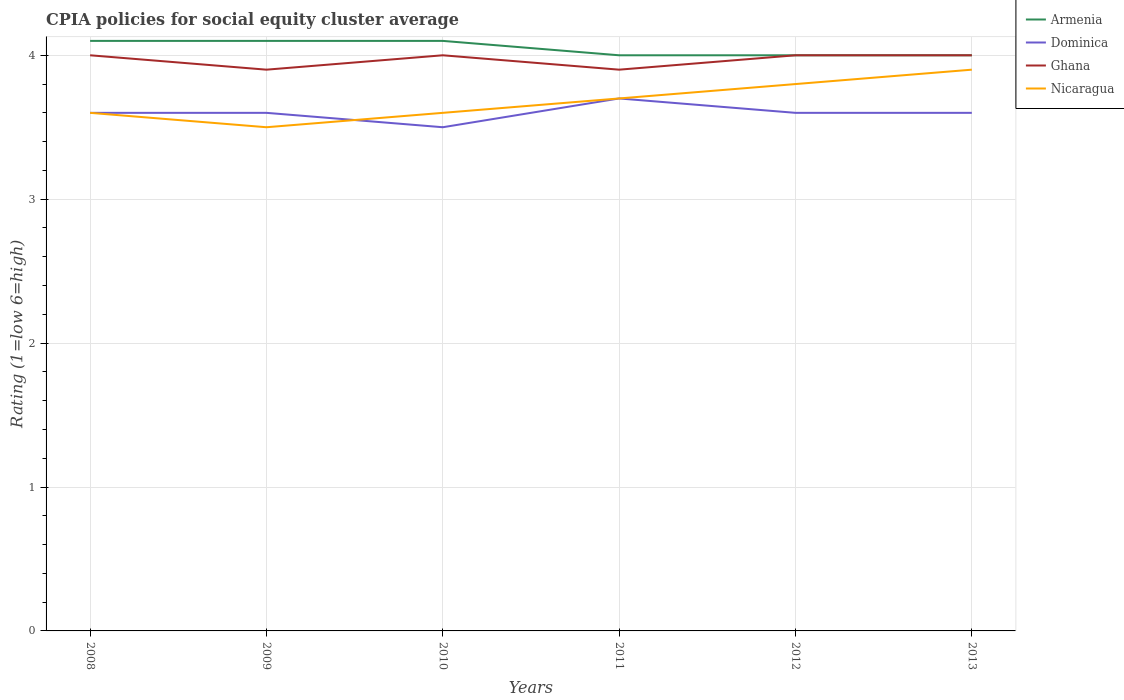How many different coloured lines are there?
Ensure brevity in your answer.  4. Does the line corresponding to Dominica intersect with the line corresponding to Ghana?
Make the answer very short. No. Across all years, what is the maximum CPIA rating in Ghana?
Keep it short and to the point. 3.9. What is the difference between the highest and the second highest CPIA rating in Dominica?
Your response must be concise. 0.2. Is the CPIA rating in Dominica strictly greater than the CPIA rating in Armenia over the years?
Give a very brief answer. Yes. How many lines are there?
Your answer should be very brief. 4. What is the difference between two consecutive major ticks on the Y-axis?
Keep it short and to the point. 1. Are the values on the major ticks of Y-axis written in scientific E-notation?
Offer a very short reply. No. What is the title of the graph?
Provide a short and direct response. CPIA policies for social equity cluster average. Does "Curacao" appear as one of the legend labels in the graph?
Make the answer very short. No. What is the label or title of the X-axis?
Offer a very short reply. Years. What is the label or title of the Y-axis?
Your answer should be compact. Rating (1=low 6=high). What is the Rating (1=low 6=high) of Armenia in 2008?
Your response must be concise. 4.1. What is the Rating (1=low 6=high) of Nicaragua in 2008?
Give a very brief answer. 3.6. What is the Rating (1=low 6=high) in Armenia in 2009?
Give a very brief answer. 4.1. What is the Rating (1=low 6=high) of Ghana in 2010?
Make the answer very short. 4. What is the Rating (1=low 6=high) in Nicaragua in 2010?
Provide a succinct answer. 3.6. What is the Rating (1=low 6=high) in Armenia in 2011?
Provide a succinct answer. 4. What is the Rating (1=low 6=high) in Ghana in 2011?
Provide a short and direct response. 3.9. What is the Rating (1=low 6=high) of Armenia in 2012?
Your answer should be compact. 4. What is the Rating (1=low 6=high) of Ghana in 2012?
Ensure brevity in your answer.  4. What is the Rating (1=low 6=high) of Nicaragua in 2012?
Provide a short and direct response. 3.8. What is the Rating (1=low 6=high) of Ghana in 2013?
Keep it short and to the point. 4. Across all years, what is the maximum Rating (1=low 6=high) of Armenia?
Ensure brevity in your answer.  4.1. Across all years, what is the maximum Rating (1=low 6=high) in Dominica?
Offer a very short reply. 3.7. Across all years, what is the maximum Rating (1=low 6=high) of Ghana?
Provide a short and direct response. 4. Across all years, what is the maximum Rating (1=low 6=high) in Nicaragua?
Your answer should be compact. 3.9. Across all years, what is the minimum Rating (1=low 6=high) in Armenia?
Ensure brevity in your answer.  4. Across all years, what is the minimum Rating (1=low 6=high) of Dominica?
Give a very brief answer. 3.5. Across all years, what is the minimum Rating (1=low 6=high) of Ghana?
Your answer should be very brief. 3.9. Across all years, what is the minimum Rating (1=low 6=high) in Nicaragua?
Offer a very short reply. 3.5. What is the total Rating (1=low 6=high) in Armenia in the graph?
Keep it short and to the point. 24.3. What is the total Rating (1=low 6=high) of Dominica in the graph?
Give a very brief answer. 21.6. What is the total Rating (1=low 6=high) in Ghana in the graph?
Give a very brief answer. 23.8. What is the total Rating (1=low 6=high) of Nicaragua in the graph?
Give a very brief answer. 22.1. What is the difference between the Rating (1=low 6=high) of Dominica in 2008 and that in 2009?
Your response must be concise. 0. What is the difference between the Rating (1=low 6=high) in Nicaragua in 2008 and that in 2009?
Offer a very short reply. 0.1. What is the difference between the Rating (1=low 6=high) of Armenia in 2008 and that in 2010?
Your response must be concise. 0. What is the difference between the Rating (1=low 6=high) in Armenia in 2008 and that in 2011?
Provide a succinct answer. 0.1. What is the difference between the Rating (1=low 6=high) in Ghana in 2008 and that in 2012?
Provide a short and direct response. 0. What is the difference between the Rating (1=low 6=high) in Ghana in 2008 and that in 2013?
Your response must be concise. 0. What is the difference between the Rating (1=low 6=high) of Nicaragua in 2008 and that in 2013?
Offer a very short reply. -0.3. What is the difference between the Rating (1=low 6=high) in Armenia in 2009 and that in 2010?
Your response must be concise. 0. What is the difference between the Rating (1=low 6=high) in Dominica in 2009 and that in 2010?
Provide a short and direct response. 0.1. What is the difference between the Rating (1=low 6=high) in Armenia in 2009 and that in 2011?
Make the answer very short. 0.1. What is the difference between the Rating (1=low 6=high) of Dominica in 2009 and that in 2011?
Offer a terse response. -0.1. What is the difference between the Rating (1=low 6=high) in Ghana in 2009 and that in 2011?
Make the answer very short. 0. What is the difference between the Rating (1=low 6=high) in Dominica in 2009 and that in 2012?
Offer a terse response. 0. What is the difference between the Rating (1=low 6=high) of Armenia in 2009 and that in 2013?
Keep it short and to the point. 0.1. What is the difference between the Rating (1=low 6=high) of Dominica in 2009 and that in 2013?
Your response must be concise. 0. What is the difference between the Rating (1=low 6=high) of Ghana in 2009 and that in 2013?
Keep it short and to the point. -0.1. What is the difference between the Rating (1=low 6=high) of Armenia in 2010 and that in 2011?
Your answer should be very brief. 0.1. What is the difference between the Rating (1=low 6=high) in Armenia in 2010 and that in 2013?
Your answer should be compact. 0.1. What is the difference between the Rating (1=low 6=high) in Dominica in 2010 and that in 2013?
Offer a terse response. -0.1. What is the difference between the Rating (1=low 6=high) of Ghana in 2010 and that in 2013?
Provide a short and direct response. 0. What is the difference between the Rating (1=low 6=high) in Armenia in 2011 and that in 2012?
Provide a short and direct response. 0. What is the difference between the Rating (1=low 6=high) in Nicaragua in 2011 and that in 2012?
Make the answer very short. -0.1. What is the difference between the Rating (1=low 6=high) in Armenia in 2011 and that in 2013?
Your response must be concise. 0. What is the difference between the Rating (1=low 6=high) of Dominica in 2011 and that in 2013?
Make the answer very short. 0.1. What is the difference between the Rating (1=low 6=high) of Ghana in 2011 and that in 2013?
Make the answer very short. -0.1. What is the difference between the Rating (1=low 6=high) in Nicaragua in 2011 and that in 2013?
Make the answer very short. -0.2. What is the difference between the Rating (1=low 6=high) of Dominica in 2012 and that in 2013?
Offer a terse response. 0. What is the difference between the Rating (1=low 6=high) of Armenia in 2008 and the Rating (1=low 6=high) of Dominica in 2009?
Your response must be concise. 0.5. What is the difference between the Rating (1=low 6=high) of Ghana in 2008 and the Rating (1=low 6=high) of Nicaragua in 2009?
Your response must be concise. 0.5. What is the difference between the Rating (1=low 6=high) of Armenia in 2008 and the Rating (1=low 6=high) of Dominica in 2010?
Offer a very short reply. 0.6. What is the difference between the Rating (1=low 6=high) of Dominica in 2008 and the Rating (1=low 6=high) of Ghana in 2010?
Provide a succinct answer. -0.4. What is the difference between the Rating (1=low 6=high) of Armenia in 2008 and the Rating (1=low 6=high) of Dominica in 2011?
Ensure brevity in your answer.  0.4. What is the difference between the Rating (1=low 6=high) in Dominica in 2008 and the Rating (1=low 6=high) in Nicaragua in 2011?
Provide a succinct answer. -0.1. What is the difference between the Rating (1=low 6=high) of Ghana in 2008 and the Rating (1=low 6=high) of Nicaragua in 2011?
Offer a very short reply. 0.3. What is the difference between the Rating (1=low 6=high) in Armenia in 2008 and the Rating (1=low 6=high) in Nicaragua in 2012?
Offer a very short reply. 0.3. What is the difference between the Rating (1=low 6=high) in Dominica in 2008 and the Rating (1=low 6=high) in Ghana in 2012?
Give a very brief answer. -0.4. What is the difference between the Rating (1=low 6=high) in Armenia in 2008 and the Rating (1=low 6=high) in Nicaragua in 2013?
Make the answer very short. 0.2. What is the difference between the Rating (1=low 6=high) of Dominica in 2008 and the Rating (1=low 6=high) of Nicaragua in 2013?
Your answer should be very brief. -0.3. What is the difference between the Rating (1=low 6=high) of Ghana in 2008 and the Rating (1=low 6=high) of Nicaragua in 2013?
Provide a succinct answer. 0.1. What is the difference between the Rating (1=low 6=high) of Armenia in 2009 and the Rating (1=low 6=high) of Nicaragua in 2010?
Offer a terse response. 0.5. What is the difference between the Rating (1=low 6=high) of Dominica in 2009 and the Rating (1=low 6=high) of Ghana in 2010?
Give a very brief answer. -0.4. What is the difference between the Rating (1=low 6=high) of Armenia in 2009 and the Rating (1=low 6=high) of Ghana in 2011?
Your answer should be very brief. 0.2. What is the difference between the Rating (1=low 6=high) in Dominica in 2009 and the Rating (1=low 6=high) in Nicaragua in 2011?
Give a very brief answer. -0.1. What is the difference between the Rating (1=low 6=high) in Ghana in 2009 and the Rating (1=low 6=high) in Nicaragua in 2011?
Your response must be concise. 0.2. What is the difference between the Rating (1=low 6=high) in Armenia in 2009 and the Rating (1=low 6=high) in Dominica in 2012?
Make the answer very short. 0.5. What is the difference between the Rating (1=low 6=high) of Armenia in 2009 and the Rating (1=low 6=high) of Ghana in 2012?
Offer a terse response. 0.1. What is the difference between the Rating (1=low 6=high) in Dominica in 2009 and the Rating (1=low 6=high) in Nicaragua in 2012?
Offer a very short reply. -0.2. What is the difference between the Rating (1=low 6=high) of Armenia in 2009 and the Rating (1=low 6=high) of Ghana in 2013?
Ensure brevity in your answer.  0.1. What is the difference between the Rating (1=low 6=high) in Dominica in 2009 and the Rating (1=low 6=high) in Ghana in 2013?
Ensure brevity in your answer.  -0.4. What is the difference between the Rating (1=low 6=high) in Ghana in 2009 and the Rating (1=low 6=high) in Nicaragua in 2013?
Offer a very short reply. 0. What is the difference between the Rating (1=low 6=high) in Armenia in 2010 and the Rating (1=low 6=high) in Dominica in 2011?
Offer a terse response. 0.4. What is the difference between the Rating (1=low 6=high) in Armenia in 2010 and the Rating (1=low 6=high) in Ghana in 2011?
Your answer should be very brief. 0.2. What is the difference between the Rating (1=low 6=high) of Dominica in 2010 and the Rating (1=low 6=high) of Ghana in 2011?
Provide a short and direct response. -0.4. What is the difference between the Rating (1=low 6=high) of Dominica in 2010 and the Rating (1=low 6=high) of Nicaragua in 2011?
Offer a very short reply. -0.2. What is the difference between the Rating (1=low 6=high) in Ghana in 2010 and the Rating (1=low 6=high) in Nicaragua in 2011?
Give a very brief answer. 0.3. What is the difference between the Rating (1=low 6=high) in Armenia in 2010 and the Rating (1=low 6=high) in Ghana in 2012?
Offer a very short reply. 0.1. What is the difference between the Rating (1=low 6=high) of Dominica in 2010 and the Rating (1=low 6=high) of Ghana in 2012?
Provide a short and direct response. -0.5. What is the difference between the Rating (1=low 6=high) in Dominica in 2010 and the Rating (1=low 6=high) in Nicaragua in 2012?
Make the answer very short. -0.3. What is the difference between the Rating (1=low 6=high) in Armenia in 2010 and the Rating (1=low 6=high) in Dominica in 2013?
Provide a succinct answer. 0.5. What is the difference between the Rating (1=low 6=high) in Dominica in 2010 and the Rating (1=low 6=high) in Ghana in 2013?
Offer a terse response. -0.5. What is the difference between the Rating (1=low 6=high) in Ghana in 2010 and the Rating (1=low 6=high) in Nicaragua in 2013?
Give a very brief answer. 0.1. What is the difference between the Rating (1=low 6=high) of Armenia in 2011 and the Rating (1=low 6=high) of Dominica in 2012?
Give a very brief answer. 0.4. What is the difference between the Rating (1=low 6=high) in Armenia in 2011 and the Rating (1=low 6=high) in Ghana in 2012?
Give a very brief answer. 0. What is the difference between the Rating (1=low 6=high) in Armenia in 2011 and the Rating (1=low 6=high) in Nicaragua in 2012?
Provide a succinct answer. 0.2. What is the difference between the Rating (1=low 6=high) of Dominica in 2011 and the Rating (1=low 6=high) of Nicaragua in 2012?
Offer a terse response. -0.1. What is the difference between the Rating (1=low 6=high) of Ghana in 2011 and the Rating (1=low 6=high) of Nicaragua in 2012?
Offer a very short reply. 0.1. What is the difference between the Rating (1=low 6=high) of Armenia in 2011 and the Rating (1=low 6=high) of Dominica in 2013?
Give a very brief answer. 0.4. What is the difference between the Rating (1=low 6=high) of Dominica in 2011 and the Rating (1=low 6=high) of Nicaragua in 2013?
Ensure brevity in your answer.  -0.2. What is the difference between the Rating (1=low 6=high) of Dominica in 2012 and the Rating (1=low 6=high) of Ghana in 2013?
Keep it short and to the point. -0.4. What is the difference between the Rating (1=low 6=high) of Dominica in 2012 and the Rating (1=low 6=high) of Nicaragua in 2013?
Your response must be concise. -0.3. What is the difference between the Rating (1=low 6=high) in Ghana in 2012 and the Rating (1=low 6=high) in Nicaragua in 2013?
Ensure brevity in your answer.  0.1. What is the average Rating (1=low 6=high) of Armenia per year?
Your answer should be very brief. 4.05. What is the average Rating (1=low 6=high) in Dominica per year?
Your answer should be very brief. 3.6. What is the average Rating (1=low 6=high) in Ghana per year?
Your answer should be very brief. 3.97. What is the average Rating (1=low 6=high) in Nicaragua per year?
Provide a succinct answer. 3.68. In the year 2008, what is the difference between the Rating (1=low 6=high) of Armenia and Rating (1=low 6=high) of Ghana?
Provide a succinct answer. 0.1. In the year 2008, what is the difference between the Rating (1=low 6=high) in Armenia and Rating (1=low 6=high) in Nicaragua?
Provide a short and direct response. 0.5. In the year 2008, what is the difference between the Rating (1=low 6=high) of Dominica and Rating (1=low 6=high) of Ghana?
Provide a short and direct response. -0.4. In the year 2008, what is the difference between the Rating (1=low 6=high) in Dominica and Rating (1=low 6=high) in Nicaragua?
Provide a succinct answer. 0. In the year 2009, what is the difference between the Rating (1=low 6=high) in Armenia and Rating (1=low 6=high) in Dominica?
Your response must be concise. 0.5. In the year 2009, what is the difference between the Rating (1=low 6=high) of Armenia and Rating (1=low 6=high) of Ghana?
Keep it short and to the point. 0.2. In the year 2009, what is the difference between the Rating (1=low 6=high) in Dominica and Rating (1=low 6=high) in Ghana?
Your answer should be very brief. -0.3. In the year 2010, what is the difference between the Rating (1=low 6=high) of Dominica and Rating (1=low 6=high) of Nicaragua?
Offer a very short reply. -0.1. In the year 2010, what is the difference between the Rating (1=low 6=high) in Ghana and Rating (1=low 6=high) in Nicaragua?
Offer a very short reply. 0.4. In the year 2011, what is the difference between the Rating (1=low 6=high) in Armenia and Rating (1=low 6=high) in Dominica?
Your answer should be compact. 0.3. In the year 2011, what is the difference between the Rating (1=low 6=high) of Armenia and Rating (1=low 6=high) of Ghana?
Give a very brief answer. 0.1. In the year 2011, what is the difference between the Rating (1=low 6=high) of Armenia and Rating (1=low 6=high) of Nicaragua?
Offer a very short reply. 0.3. In the year 2011, what is the difference between the Rating (1=low 6=high) of Dominica and Rating (1=low 6=high) of Ghana?
Make the answer very short. -0.2. In the year 2011, what is the difference between the Rating (1=low 6=high) of Dominica and Rating (1=low 6=high) of Nicaragua?
Provide a short and direct response. 0. In the year 2011, what is the difference between the Rating (1=low 6=high) of Ghana and Rating (1=low 6=high) of Nicaragua?
Your response must be concise. 0.2. In the year 2012, what is the difference between the Rating (1=low 6=high) in Armenia and Rating (1=low 6=high) in Nicaragua?
Your answer should be very brief. 0.2. In the year 2012, what is the difference between the Rating (1=low 6=high) of Dominica and Rating (1=low 6=high) of Ghana?
Offer a very short reply. -0.4. In the year 2012, what is the difference between the Rating (1=low 6=high) in Dominica and Rating (1=low 6=high) in Nicaragua?
Your answer should be very brief. -0.2. In the year 2013, what is the difference between the Rating (1=low 6=high) of Armenia and Rating (1=low 6=high) of Dominica?
Make the answer very short. 0.4. In the year 2013, what is the difference between the Rating (1=low 6=high) of Armenia and Rating (1=low 6=high) of Nicaragua?
Keep it short and to the point. 0.1. In the year 2013, what is the difference between the Rating (1=low 6=high) of Dominica and Rating (1=low 6=high) of Nicaragua?
Give a very brief answer. -0.3. What is the ratio of the Rating (1=low 6=high) in Ghana in 2008 to that in 2009?
Your answer should be very brief. 1.03. What is the ratio of the Rating (1=low 6=high) of Nicaragua in 2008 to that in 2009?
Your answer should be very brief. 1.03. What is the ratio of the Rating (1=low 6=high) in Dominica in 2008 to that in 2010?
Make the answer very short. 1.03. What is the ratio of the Rating (1=low 6=high) of Ghana in 2008 to that in 2010?
Provide a short and direct response. 1. What is the ratio of the Rating (1=low 6=high) in Nicaragua in 2008 to that in 2010?
Provide a short and direct response. 1. What is the ratio of the Rating (1=low 6=high) of Armenia in 2008 to that in 2011?
Offer a terse response. 1.02. What is the ratio of the Rating (1=low 6=high) of Ghana in 2008 to that in 2011?
Keep it short and to the point. 1.03. What is the ratio of the Rating (1=low 6=high) of Nicaragua in 2008 to that in 2011?
Keep it short and to the point. 0.97. What is the ratio of the Rating (1=low 6=high) in Armenia in 2008 to that in 2012?
Keep it short and to the point. 1.02. What is the ratio of the Rating (1=low 6=high) of Nicaragua in 2008 to that in 2012?
Your response must be concise. 0.95. What is the ratio of the Rating (1=low 6=high) in Nicaragua in 2008 to that in 2013?
Your answer should be compact. 0.92. What is the ratio of the Rating (1=low 6=high) in Dominica in 2009 to that in 2010?
Your response must be concise. 1.03. What is the ratio of the Rating (1=low 6=high) in Ghana in 2009 to that in 2010?
Your answer should be compact. 0.97. What is the ratio of the Rating (1=low 6=high) in Nicaragua in 2009 to that in 2010?
Give a very brief answer. 0.97. What is the ratio of the Rating (1=low 6=high) in Armenia in 2009 to that in 2011?
Your answer should be compact. 1.02. What is the ratio of the Rating (1=low 6=high) in Nicaragua in 2009 to that in 2011?
Give a very brief answer. 0.95. What is the ratio of the Rating (1=low 6=high) of Armenia in 2009 to that in 2012?
Ensure brevity in your answer.  1.02. What is the ratio of the Rating (1=low 6=high) of Dominica in 2009 to that in 2012?
Your response must be concise. 1. What is the ratio of the Rating (1=low 6=high) in Ghana in 2009 to that in 2012?
Offer a terse response. 0.97. What is the ratio of the Rating (1=low 6=high) in Nicaragua in 2009 to that in 2012?
Provide a short and direct response. 0.92. What is the ratio of the Rating (1=low 6=high) in Dominica in 2009 to that in 2013?
Your answer should be compact. 1. What is the ratio of the Rating (1=low 6=high) of Ghana in 2009 to that in 2013?
Make the answer very short. 0.97. What is the ratio of the Rating (1=low 6=high) of Nicaragua in 2009 to that in 2013?
Offer a terse response. 0.9. What is the ratio of the Rating (1=low 6=high) of Armenia in 2010 to that in 2011?
Ensure brevity in your answer.  1.02. What is the ratio of the Rating (1=low 6=high) of Dominica in 2010 to that in 2011?
Make the answer very short. 0.95. What is the ratio of the Rating (1=low 6=high) in Ghana in 2010 to that in 2011?
Offer a very short reply. 1.03. What is the ratio of the Rating (1=low 6=high) of Nicaragua in 2010 to that in 2011?
Your response must be concise. 0.97. What is the ratio of the Rating (1=low 6=high) in Dominica in 2010 to that in 2012?
Your answer should be very brief. 0.97. What is the ratio of the Rating (1=low 6=high) of Nicaragua in 2010 to that in 2012?
Provide a short and direct response. 0.95. What is the ratio of the Rating (1=low 6=high) of Armenia in 2010 to that in 2013?
Provide a succinct answer. 1.02. What is the ratio of the Rating (1=low 6=high) of Dominica in 2010 to that in 2013?
Make the answer very short. 0.97. What is the ratio of the Rating (1=low 6=high) in Ghana in 2010 to that in 2013?
Keep it short and to the point. 1. What is the ratio of the Rating (1=low 6=high) in Dominica in 2011 to that in 2012?
Ensure brevity in your answer.  1.03. What is the ratio of the Rating (1=low 6=high) in Nicaragua in 2011 to that in 2012?
Offer a terse response. 0.97. What is the ratio of the Rating (1=low 6=high) of Armenia in 2011 to that in 2013?
Give a very brief answer. 1. What is the ratio of the Rating (1=low 6=high) in Dominica in 2011 to that in 2013?
Give a very brief answer. 1.03. What is the ratio of the Rating (1=low 6=high) of Nicaragua in 2011 to that in 2013?
Give a very brief answer. 0.95. What is the ratio of the Rating (1=low 6=high) of Armenia in 2012 to that in 2013?
Make the answer very short. 1. What is the ratio of the Rating (1=low 6=high) of Nicaragua in 2012 to that in 2013?
Give a very brief answer. 0.97. What is the difference between the highest and the second highest Rating (1=low 6=high) in Ghana?
Provide a short and direct response. 0. What is the difference between the highest and the lowest Rating (1=low 6=high) of Armenia?
Offer a terse response. 0.1. What is the difference between the highest and the lowest Rating (1=low 6=high) in Ghana?
Give a very brief answer. 0.1. 